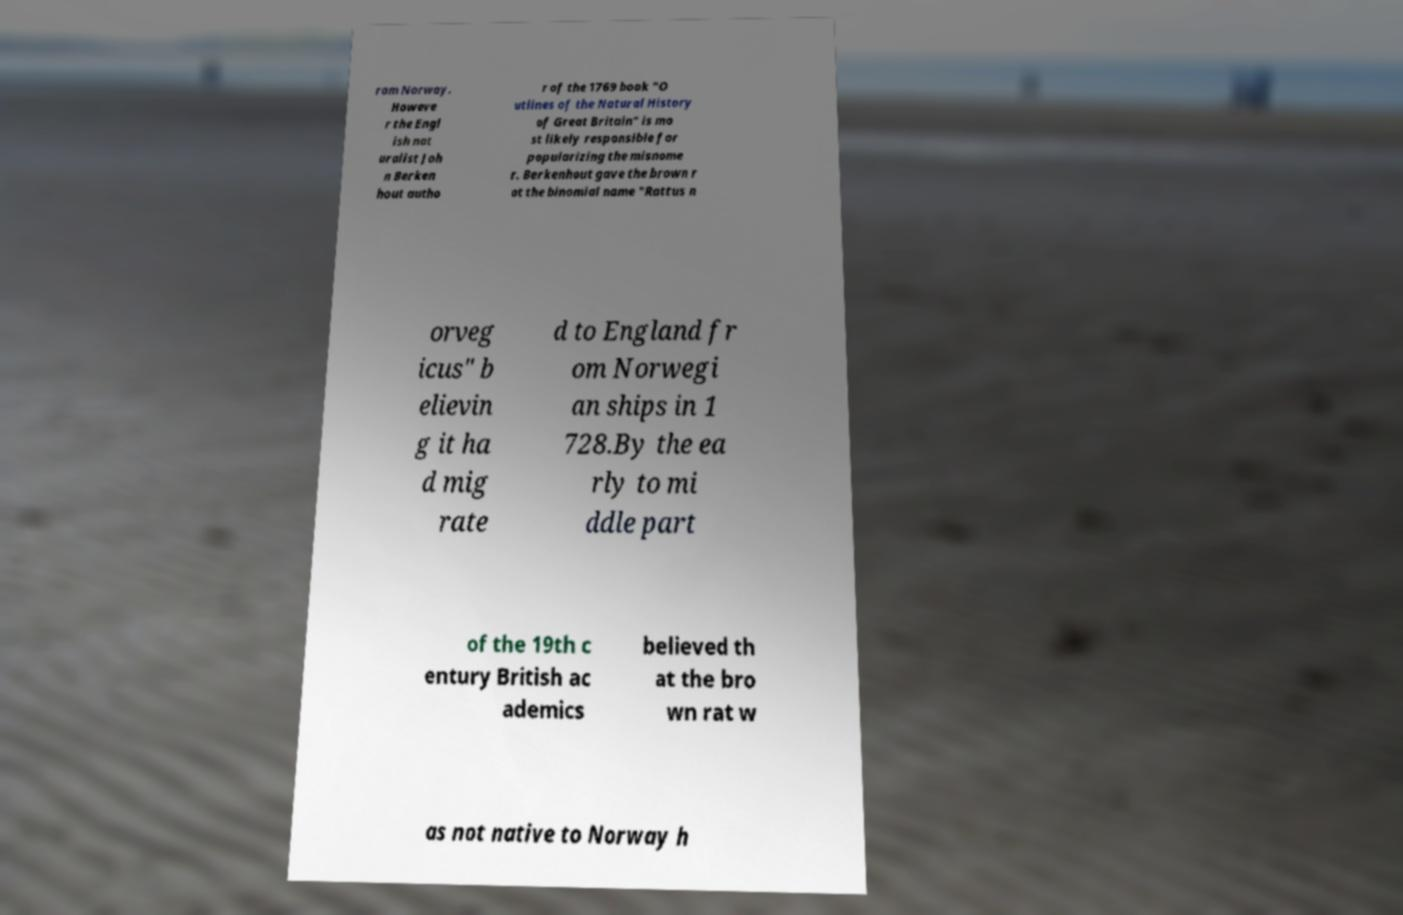I need the written content from this picture converted into text. Can you do that? rom Norway. Howeve r the Engl ish nat uralist Joh n Berken hout autho r of the 1769 book "O utlines of the Natural History of Great Britain" is mo st likely responsible for popularizing the misnome r. Berkenhout gave the brown r at the binomial name "Rattus n orveg icus" b elievin g it ha d mig rate d to England fr om Norwegi an ships in 1 728.By the ea rly to mi ddle part of the 19th c entury British ac ademics believed th at the bro wn rat w as not native to Norway h 